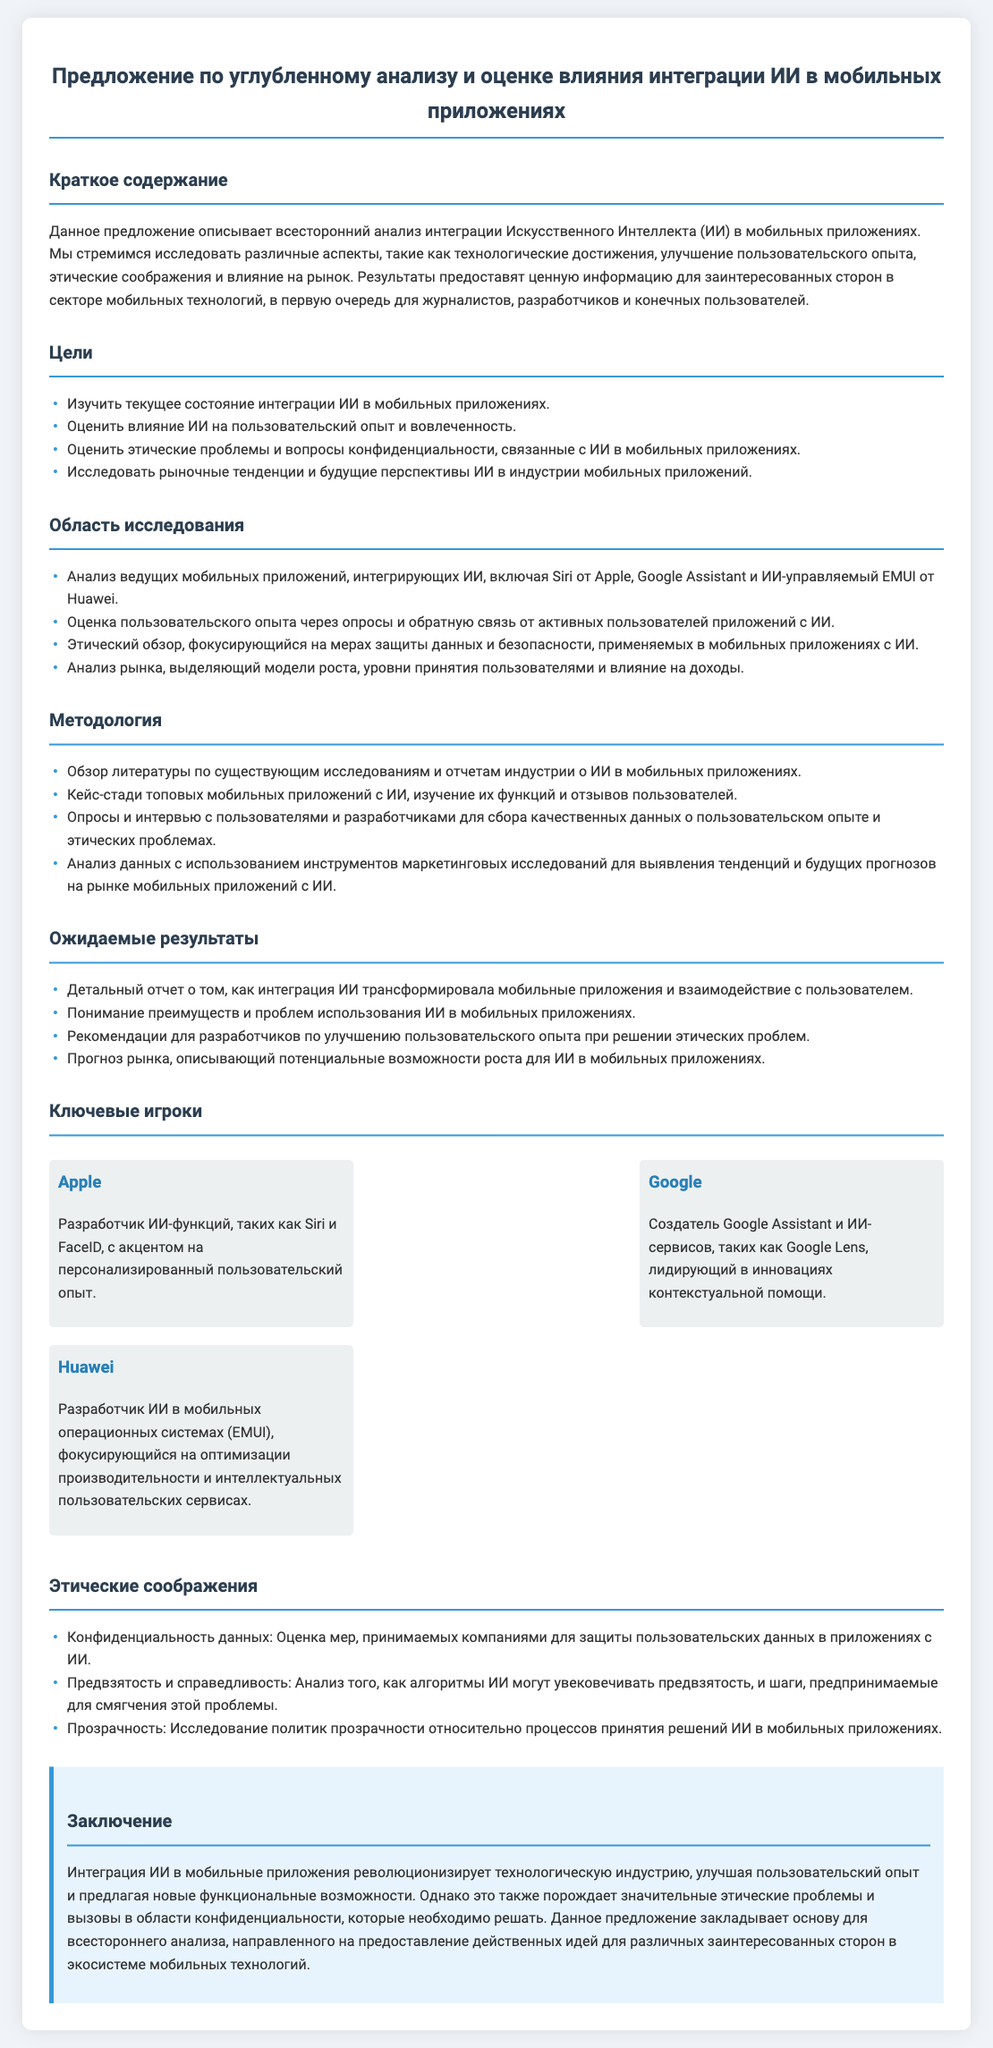Какова цель анализа интеграции ИИ в мобильных приложениях? Цели анализа охватывают исследование текущего состояния, оценку влияния на пользовательский опыт, этические проблемы и рыночные тенденции.
Answer: Исследовать текущее состояние интеграции ИИ в мобильных приложениях Какой метод используется для оценки пользовательского опыта? Методология включает опросы и обратную связь от пользователей приложений с ИИ.
Answer: Опросы и обратная связь Кто является разработчиком Siri? В документе указано, что Apple разработала функцию Siri.
Answer: Apple Каковы ключевые этические соображения, упомянутые в документе? Эти проблемы касаются конфиденциальности данных, предвзятости и прозрачности.
Answer: Конфиденциальность данных, предвзятость и справедливость, прозрачность Кто разработал Google Assistant? Создателем Google Assistant является компания Google, как указано в тексте.
Answer: Google Какова ожидаемая структура отчета? Ожидается детальный отчет, который описывает трансформацию мобильных приложений и взаимодействие с пользователем.
Answer: Детальный отчет о том, как интеграция ИИ трансформировала мобильные приложения и взаимодействие с пользователем Какой элемент документа описывает ключевых игроков в индустрии? Раздел "Ключевые игроки" иллюстрирует основные компании и их вклад в интеграцию ИИ.
Answer: Ключевые игроки Какова основная тема заключения? Заключение подчеркивает революционное влияние ИИ на технологии и возникающие этические проблемы.
Answer: Интеграция ИИ в мобильные приложения революционизирует технологическую индустрию 